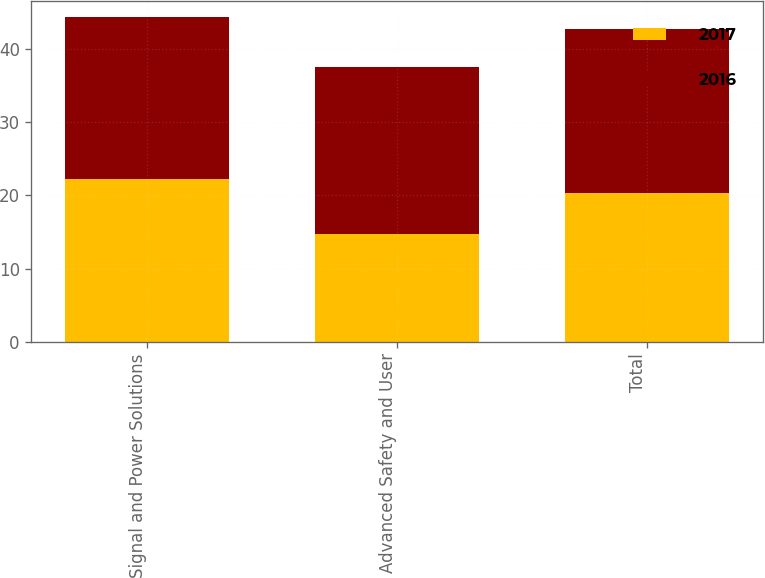Convert chart to OTSL. <chart><loc_0><loc_0><loc_500><loc_500><stacked_bar_chart><ecel><fcel>Signal and Power Solutions<fcel>Advanced Safety and User<fcel>Total<nl><fcel>2017<fcel>22.2<fcel>14.7<fcel>20.3<nl><fcel>2016<fcel>22.1<fcel>22.8<fcel>22.4<nl></chart> 